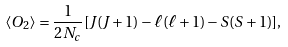<formula> <loc_0><loc_0><loc_500><loc_500>\langle O _ { 2 } \rangle = \frac { 1 } { 2 N _ { c } } [ J ( J + 1 ) - \ell ( \ell + 1 ) - S ( S + 1 ) ] ,</formula> 